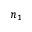Convert formula to latex. <formula><loc_0><loc_0><loc_500><loc_500>n _ { 1 }</formula> 